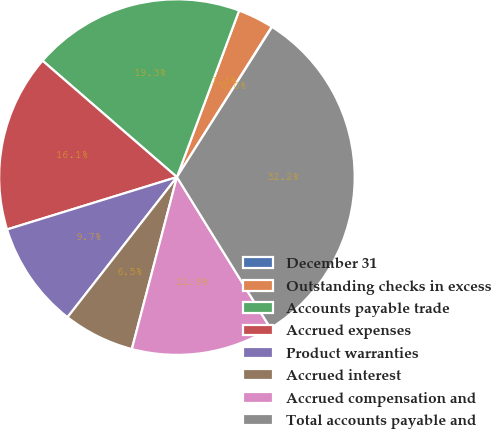Convert chart. <chart><loc_0><loc_0><loc_500><loc_500><pie_chart><fcel>December 31<fcel>Outstanding checks in excess<fcel>Accounts payable trade<fcel>Accrued expenses<fcel>Product warranties<fcel>Accrued interest<fcel>Accrued compensation and<fcel>Total accounts payable and<nl><fcel>0.04%<fcel>3.26%<fcel>19.33%<fcel>16.12%<fcel>9.69%<fcel>6.47%<fcel>12.9%<fcel>32.19%<nl></chart> 